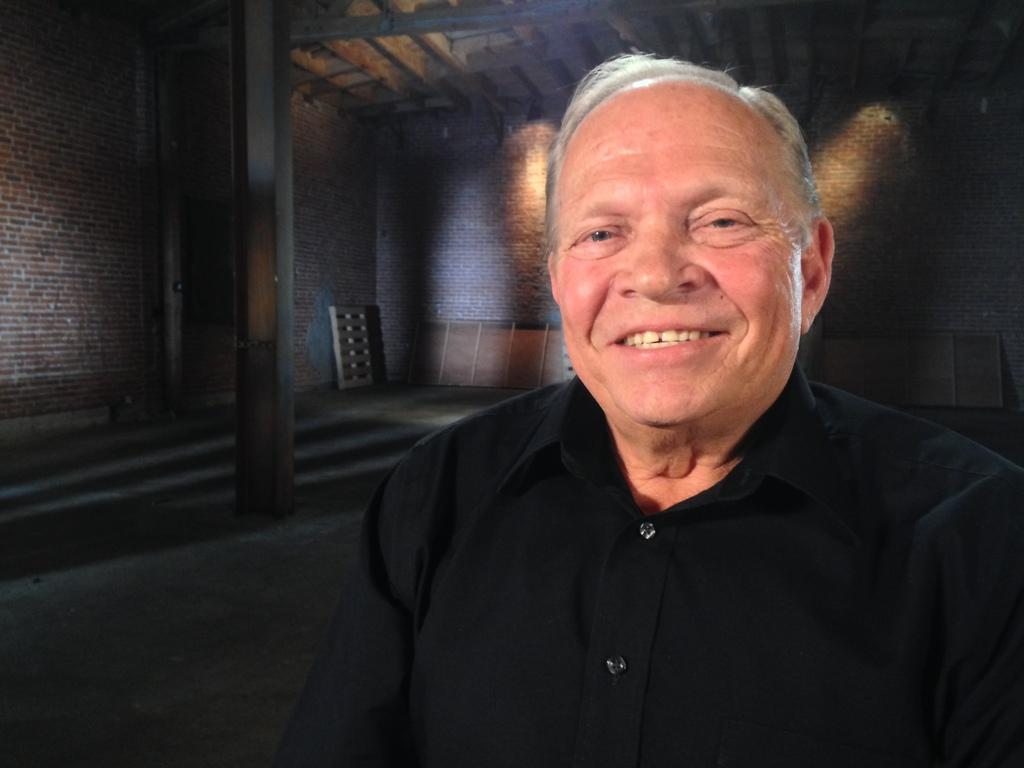Who is present in the image? There is a man in the image. What is the man doing in the image? The man is smiling in the image. What is the man wearing in the image? The man is wearing a black color shirt in the image. What can be seen in the background of the image? There is a wall in the background of the image. What architectural feature is present in the image? There is a pillar in the image. What type of stew is being prepared in the image? There is no stew present in the image; it features a man smiling while wearing a black color shirt. Can you tell me how many ears the man has in the image? The image does not show the man's ears, so it is not possible to determine the number of ears he has. 